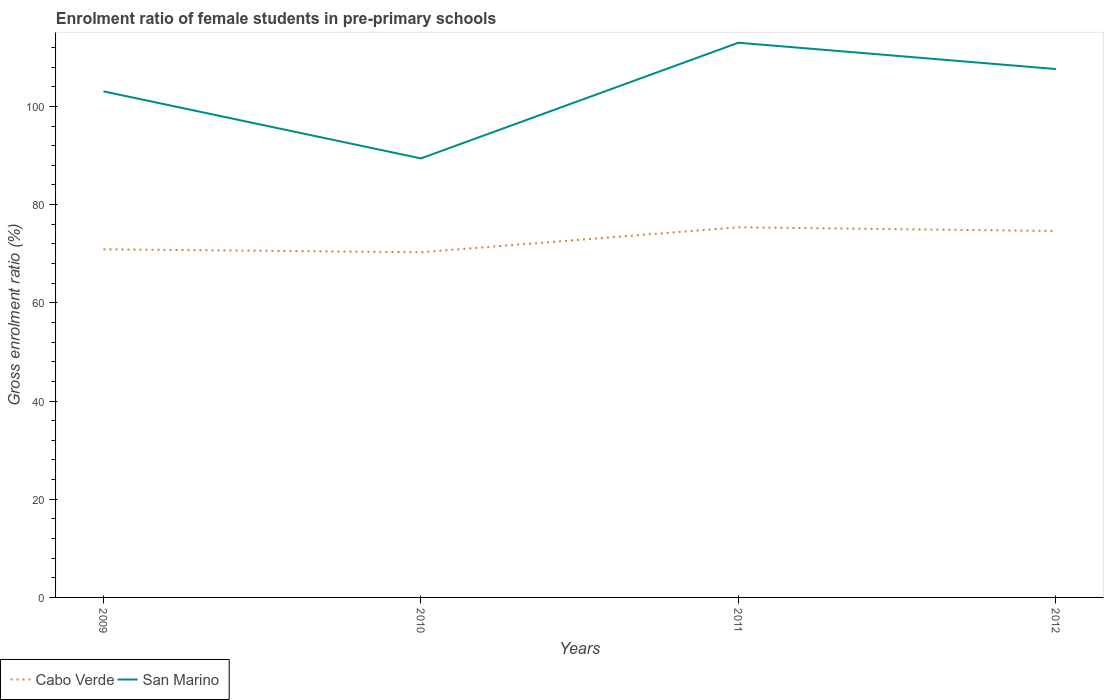Is the number of lines equal to the number of legend labels?
Your answer should be very brief. Yes. Across all years, what is the maximum enrolment ratio of female students in pre-primary schools in San Marino?
Ensure brevity in your answer.  89.41. In which year was the enrolment ratio of female students in pre-primary schools in San Marino maximum?
Make the answer very short. 2010. What is the total enrolment ratio of female students in pre-primary schools in Cabo Verde in the graph?
Keep it short and to the point. -4.48. What is the difference between the highest and the second highest enrolment ratio of female students in pre-primary schools in Cabo Verde?
Your answer should be very brief. 5.09. What is the difference between the highest and the lowest enrolment ratio of female students in pre-primary schools in Cabo Verde?
Your response must be concise. 2. Is the enrolment ratio of female students in pre-primary schools in San Marino strictly greater than the enrolment ratio of female students in pre-primary schools in Cabo Verde over the years?
Provide a short and direct response. No. How many lines are there?
Provide a succinct answer. 2. How many years are there in the graph?
Offer a terse response. 4. What is the difference between two consecutive major ticks on the Y-axis?
Your response must be concise. 20. Are the values on the major ticks of Y-axis written in scientific E-notation?
Keep it short and to the point. No. What is the title of the graph?
Your response must be concise. Enrolment ratio of female students in pre-primary schools. What is the label or title of the Y-axis?
Make the answer very short. Gross enrolment ratio (%). What is the Gross enrolment ratio (%) in Cabo Verde in 2009?
Keep it short and to the point. 70.9. What is the Gross enrolment ratio (%) in San Marino in 2009?
Your answer should be compact. 103.07. What is the Gross enrolment ratio (%) of Cabo Verde in 2010?
Make the answer very short. 70.3. What is the Gross enrolment ratio (%) in San Marino in 2010?
Provide a short and direct response. 89.41. What is the Gross enrolment ratio (%) in Cabo Verde in 2011?
Make the answer very short. 75.39. What is the Gross enrolment ratio (%) of San Marino in 2011?
Your answer should be very brief. 112.98. What is the Gross enrolment ratio (%) in Cabo Verde in 2012?
Your answer should be very brief. 74.63. What is the Gross enrolment ratio (%) of San Marino in 2012?
Offer a very short reply. 107.62. Across all years, what is the maximum Gross enrolment ratio (%) of Cabo Verde?
Give a very brief answer. 75.39. Across all years, what is the maximum Gross enrolment ratio (%) in San Marino?
Provide a succinct answer. 112.98. Across all years, what is the minimum Gross enrolment ratio (%) of Cabo Verde?
Keep it short and to the point. 70.3. Across all years, what is the minimum Gross enrolment ratio (%) in San Marino?
Keep it short and to the point. 89.41. What is the total Gross enrolment ratio (%) of Cabo Verde in the graph?
Keep it short and to the point. 291.22. What is the total Gross enrolment ratio (%) of San Marino in the graph?
Keep it short and to the point. 413.08. What is the difference between the Gross enrolment ratio (%) of Cabo Verde in 2009 and that in 2010?
Give a very brief answer. 0.6. What is the difference between the Gross enrolment ratio (%) in San Marino in 2009 and that in 2010?
Offer a very short reply. 13.66. What is the difference between the Gross enrolment ratio (%) of Cabo Verde in 2009 and that in 2011?
Your answer should be compact. -4.48. What is the difference between the Gross enrolment ratio (%) of San Marino in 2009 and that in 2011?
Provide a succinct answer. -9.91. What is the difference between the Gross enrolment ratio (%) of Cabo Verde in 2009 and that in 2012?
Your response must be concise. -3.73. What is the difference between the Gross enrolment ratio (%) in San Marino in 2009 and that in 2012?
Provide a succinct answer. -4.55. What is the difference between the Gross enrolment ratio (%) of Cabo Verde in 2010 and that in 2011?
Your response must be concise. -5.09. What is the difference between the Gross enrolment ratio (%) of San Marino in 2010 and that in 2011?
Offer a terse response. -23.56. What is the difference between the Gross enrolment ratio (%) in Cabo Verde in 2010 and that in 2012?
Provide a short and direct response. -4.33. What is the difference between the Gross enrolment ratio (%) of San Marino in 2010 and that in 2012?
Keep it short and to the point. -18.2. What is the difference between the Gross enrolment ratio (%) of Cabo Verde in 2011 and that in 2012?
Ensure brevity in your answer.  0.75. What is the difference between the Gross enrolment ratio (%) in San Marino in 2011 and that in 2012?
Offer a very short reply. 5.36. What is the difference between the Gross enrolment ratio (%) in Cabo Verde in 2009 and the Gross enrolment ratio (%) in San Marino in 2010?
Keep it short and to the point. -18.51. What is the difference between the Gross enrolment ratio (%) in Cabo Verde in 2009 and the Gross enrolment ratio (%) in San Marino in 2011?
Ensure brevity in your answer.  -42.07. What is the difference between the Gross enrolment ratio (%) in Cabo Verde in 2009 and the Gross enrolment ratio (%) in San Marino in 2012?
Offer a very short reply. -36.71. What is the difference between the Gross enrolment ratio (%) of Cabo Verde in 2010 and the Gross enrolment ratio (%) of San Marino in 2011?
Give a very brief answer. -42.67. What is the difference between the Gross enrolment ratio (%) in Cabo Verde in 2010 and the Gross enrolment ratio (%) in San Marino in 2012?
Make the answer very short. -37.32. What is the difference between the Gross enrolment ratio (%) of Cabo Verde in 2011 and the Gross enrolment ratio (%) of San Marino in 2012?
Provide a short and direct response. -32.23. What is the average Gross enrolment ratio (%) in Cabo Verde per year?
Give a very brief answer. 72.81. What is the average Gross enrolment ratio (%) in San Marino per year?
Your answer should be very brief. 103.27. In the year 2009, what is the difference between the Gross enrolment ratio (%) in Cabo Verde and Gross enrolment ratio (%) in San Marino?
Keep it short and to the point. -32.17. In the year 2010, what is the difference between the Gross enrolment ratio (%) in Cabo Verde and Gross enrolment ratio (%) in San Marino?
Your answer should be very brief. -19.11. In the year 2011, what is the difference between the Gross enrolment ratio (%) in Cabo Verde and Gross enrolment ratio (%) in San Marino?
Keep it short and to the point. -37.59. In the year 2012, what is the difference between the Gross enrolment ratio (%) in Cabo Verde and Gross enrolment ratio (%) in San Marino?
Provide a short and direct response. -32.98. What is the ratio of the Gross enrolment ratio (%) in Cabo Verde in 2009 to that in 2010?
Provide a short and direct response. 1.01. What is the ratio of the Gross enrolment ratio (%) in San Marino in 2009 to that in 2010?
Provide a succinct answer. 1.15. What is the ratio of the Gross enrolment ratio (%) of Cabo Verde in 2009 to that in 2011?
Keep it short and to the point. 0.94. What is the ratio of the Gross enrolment ratio (%) in San Marino in 2009 to that in 2011?
Offer a very short reply. 0.91. What is the ratio of the Gross enrolment ratio (%) in Cabo Verde in 2009 to that in 2012?
Your answer should be compact. 0.95. What is the ratio of the Gross enrolment ratio (%) of San Marino in 2009 to that in 2012?
Offer a very short reply. 0.96. What is the ratio of the Gross enrolment ratio (%) of Cabo Verde in 2010 to that in 2011?
Give a very brief answer. 0.93. What is the ratio of the Gross enrolment ratio (%) in San Marino in 2010 to that in 2011?
Ensure brevity in your answer.  0.79. What is the ratio of the Gross enrolment ratio (%) in Cabo Verde in 2010 to that in 2012?
Make the answer very short. 0.94. What is the ratio of the Gross enrolment ratio (%) of San Marino in 2010 to that in 2012?
Give a very brief answer. 0.83. What is the ratio of the Gross enrolment ratio (%) of San Marino in 2011 to that in 2012?
Offer a terse response. 1.05. What is the difference between the highest and the second highest Gross enrolment ratio (%) of Cabo Verde?
Your response must be concise. 0.75. What is the difference between the highest and the second highest Gross enrolment ratio (%) in San Marino?
Offer a terse response. 5.36. What is the difference between the highest and the lowest Gross enrolment ratio (%) of Cabo Verde?
Offer a terse response. 5.09. What is the difference between the highest and the lowest Gross enrolment ratio (%) in San Marino?
Give a very brief answer. 23.56. 